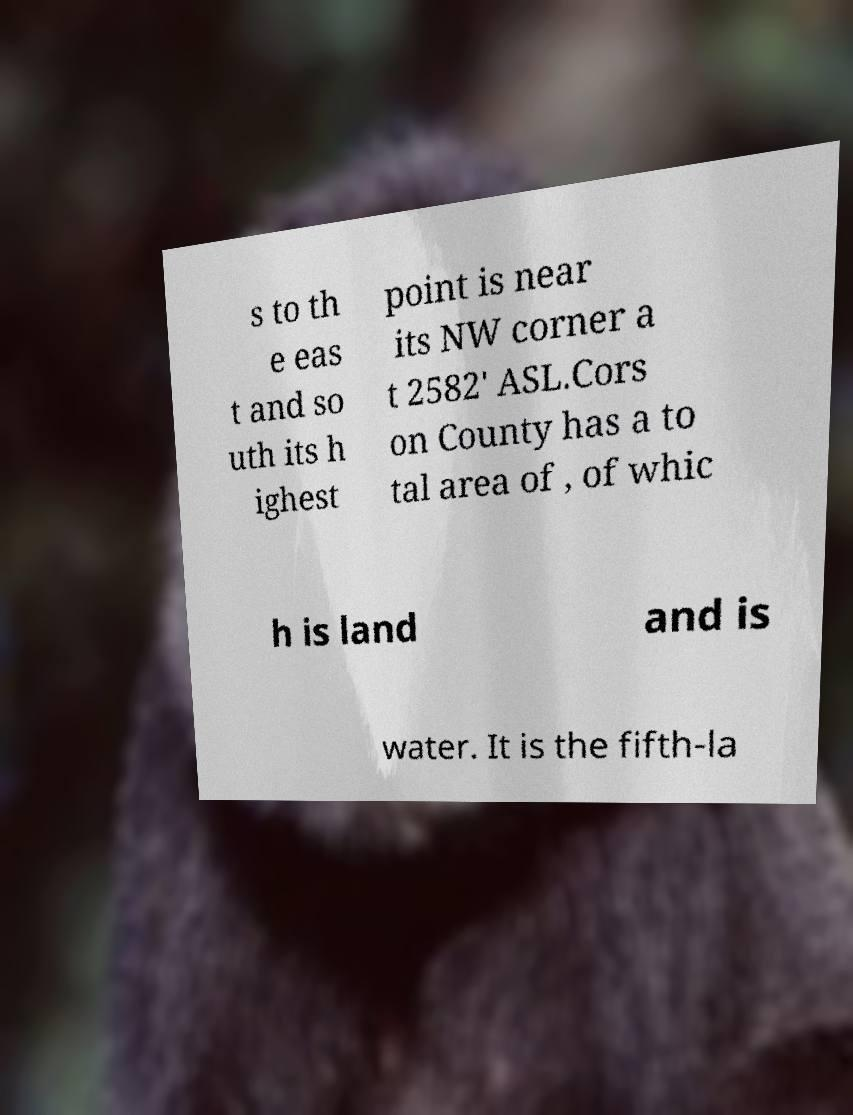Please read and relay the text visible in this image. What does it say? s to th e eas t and so uth its h ighest point is near its NW corner a t 2582' ASL.Cors on County has a to tal area of , of whic h is land and is water. It is the fifth-la 